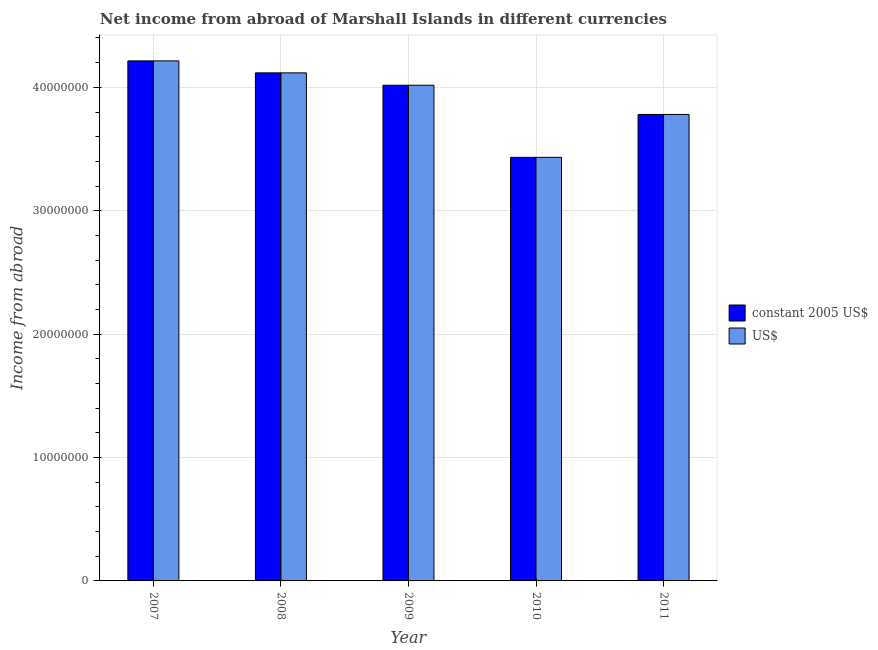How many different coloured bars are there?
Keep it short and to the point. 2. How many groups of bars are there?
Ensure brevity in your answer.  5. Are the number of bars per tick equal to the number of legend labels?
Provide a short and direct response. Yes. How many bars are there on the 2nd tick from the right?
Give a very brief answer. 2. What is the label of the 5th group of bars from the left?
Make the answer very short. 2011. What is the income from abroad in us$ in 2010?
Your response must be concise. 3.43e+07. Across all years, what is the maximum income from abroad in us$?
Provide a succinct answer. 4.21e+07. Across all years, what is the minimum income from abroad in us$?
Ensure brevity in your answer.  3.43e+07. In which year was the income from abroad in constant 2005 us$ minimum?
Ensure brevity in your answer.  2010. What is the total income from abroad in constant 2005 us$ in the graph?
Provide a short and direct response. 1.96e+08. What is the difference between the income from abroad in constant 2005 us$ in 2009 and that in 2010?
Your answer should be very brief. 5.84e+06. What is the difference between the income from abroad in constant 2005 us$ in 2008 and the income from abroad in us$ in 2010?
Give a very brief answer. 6.85e+06. What is the average income from abroad in constant 2005 us$ per year?
Keep it short and to the point. 3.91e+07. In how many years, is the income from abroad in us$ greater than 12000000 units?
Make the answer very short. 5. What is the ratio of the income from abroad in us$ in 2007 to that in 2009?
Make the answer very short. 1.05. Is the income from abroad in constant 2005 us$ in 2008 less than that in 2009?
Ensure brevity in your answer.  No. What is the difference between the highest and the second highest income from abroad in us$?
Ensure brevity in your answer.  9.72e+05. What is the difference between the highest and the lowest income from abroad in us$?
Provide a succinct answer. 7.82e+06. In how many years, is the income from abroad in constant 2005 us$ greater than the average income from abroad in constant 2005 us$ taken over all years?
Your response must be concise. 3. What does the 1st bar from the left in 2010 represents?
Offer a very short reply. Constant 2005 us$. What does the 1st bar from the right in 2010 represents?
Ensure brevity in your answer.  US$. How many bars are there?
Your answer should be very brief. 10. Are the values on the major ticks of Y-axis written in scientific E-notation?
Keep it short and to the point. No. Does the graph contain any zero values?
Your answer should be very brief. No. Where does the legend appear in the graph?
Offer a very short reply. Center right. How are the legend labels stacked?
Provide a succinct answer. Vertical. What is the title of the graph?
Provide a short and direct response. Net income from abroad of Marshall Islands in different currencies. What is the label or title of the Y-axis?
Ensure brevity in your answer.  Income from abroad. What is the Income from abroad in constant 2005 US$ in 2007?
Your answer should be compact. 4.21e+07. What is the Income from abroad of US$ in 2007?
Your response must be concise. 4.21e+07. What is the Income from abroad in constant 2005 US$ in 2008?
Offer a terse response. 4.12e+07. What is the Income from abroad in US$ in 2008?
Make the answer very short. 4.12e+07. What is the Income from abroad in constant 2005 US$ in 2009?
Provide a short and direct response. 4.02e+07. What is the Income from abroad of US$ in 2009?
Ensure brevity in your answer.  4.02e+07. What is the Income from abroad in constant 2005 US$ in 2010?
Your answer should be compact. 3.43e+07. What is the Income from abroad in US$ in 2010?
Offer a terse response. 3.43e+07. What is the Income from abroad in constant 2005 US$ in 2011?
Your answer should be very brief. 3.78e+07. What is the Income from abroad of US$ in 2011?
Provide a succinct answer. 3.78e+07. Across all years, what is the maximum Income from abroad in constant 2005 US$?
Keep it short and to the point. 4.21e+07. Across all years, what is the maximum Income from abroad in US$?
Give a very brief answer. 4.21e+07. Across all years, what is the minimum Income from abroad of constant 2005 US$?
Provide a succinct answer. 3.43e+07. Across all years, what is the minimum Income from abroad in US$?
Offer a very short reply. 3.43e+07. What is the total Income from abroad of constant 2005 US$ in the graph?
Your answer should be very brief. 1.96e+08. What is the total Income from abroad in US$ in the graph?
Offer a terse response. 1.96e+08. What is the difference between the Income from abroad of constant 2005 US$ in 2007 and that in 2008?
Give a very brief answer. 9.72e+05. What is the difference between the Income from abroad of US$ in 2007 and that in 2008?
Your answer should be compact. 9.72e+05. What is the difference between the Income from abroad in constant 2005 US$ in 2007 and that in 2009?
Provide a succinct answer. 1.97e+06. What is the difference between the Income from abroad in US$ in 2007 and that in 2009?
Ensure brevity in your answer.  1.97e+06. What is the difference between the Income from abroad in constant 2005 US$ in 2007 and that in 2010?
Your response must be concise. 7.82e+06. What is the difference between the Income from abroad in US$ in 2007 and that in 2010?
Make the answer very short. 7.82e+06. What is the difference between the Income from abroad of constant 2005 US$ in 2007 and that in 2011?
Your answer should be compact. 4.34e+06. What is the difference between the Income from abroad in US$ in 2007 and that in 2011?
Provide a succinct answer. 4.34e+06. What is the difference between the Income from abroad of constant 2005 US$ in 2008 and that in 2009?
Your answer should be compact. 1.00e+06. What is the difference between the Income from abroad of US$ in 2008 and that in 2009?
Offer a very short reply. 1.00e+06. What is the difference between the Income from abroad of constant 2005 US$ in 2008 and that in 2010?
Your answer should be compact. 6.85e+06. What is the difference between the Income from abroad of US$ in 2008 and that in 2010?
Make the answer very short. 6.85e+06. What is the difference between the Income from abroad in constant 2005 US$ in 2008 and that in 2011?
Keep it short and to the point. 3.37e+06. What is the difference between the Income from abroad in US$ in 2008 and that in 2011?
Make the answer very short. 3.37e+06. What is the difference between the Income from abroad in constant 2005 US$ in 2009 and that in 2010?
Your answer should be compact. 5.84e+06. What is the difference between the Income from abroad in US$ in 2009 and that in 2010?
Offer a terse response. 5.84e+06. What is the difference between the Income from abroad of constant 2005 US$ in 2009 and that in 2011?
Provide a succinct answer. 2.37e+06. What is the difference between the Income from abroad in US$ in 2009 and that in 2011?
Give a very brief answer. 2.37e+06. What is the difference between the Income from abroad of constant 2005 US$ in 2010 and that in 2011?
Provide a succinct answer. -3.48e+06. What is the difference between the Income from abroad of US$ in 2010 and that in 2011?
Ensure brevity in your answer.  -3.48e+06. What is the difference between the Income from abroad of constant 2005 US$ in 2007 and the Income from abroad of US$ in 2008?
Keep it short and to the point. 9.72e+05. What is the difference between the Income from abroad in constant 2005 US$ in 2007 and the Income from abroad in US$ in 2009?
Provide a succinct answer. 1.97e+06. What is the difference between the Income from abroad in constant 2005 US$ in 2007 and the Income from abroad in US$ in 2010?
Provide a succinct answer. 7.82e+06. What is the difference between the Income from abroad in constant 2005 US$ in 2007 and the Income from abroad in US$ in 2011?
Give a very brief answer. 4.34e+06. What is the difference between the Income from abroad of constant 2005 US$ in 2008 and the Income from abroad of US$ in 2009?
Provide a short and direct response. 1.00e+06. What is the difference between the Income from abroad of constant 2005 US$ in 2008 and the Income from abroad of US$ in 2010?
Offer a very short reply. 6.85e+06. What is the difference between the Income from abroad in constant 2005 US$ in 2008 and the Income from abroad in US$ in 2011?
Offer a terse response. 3.37e+06. What is the difference between the Income from abroad of constant 2005 US$ in 2009 and the Income from abroad of US$ in 2010?
Your response must be concise. 5.84e+06. What is the difference between the Income from abroad in constant 2005 US$ in 2009 and the Income from abroad in US$ in 2011?
Offer a terse response. 2.37e+06. What is the difference between the Income from abroad in constant 2005 US$ in 2010 and the Income from abroad in US$ in 2011?
Keep it short and to the point. -3.48e+06. What is the average Income from abroad in constant 2005 US$ per year?
Keep it short and to the point. 3.91e+07. What is the average Income from abroad of US$ per year?
Your answer should be very brief. 3.91e+07. In the year 2007, what is the difference between the Income from abroad in constant 2005 US$ and Income from abroad in US$?
Your response must be concise. 0. In the year 2008, what is the difference between the Income from abroad of constant 2005 US$ and Income from abroad of US$?
Give a very brief answer. 0. In the year 2009, what is the difference between the Income from abroad in constant 2005 US$ and Income from abroad in US$?
Provide a succinct answer. 0. In the year 2010, what is the difference between the Income from abroad in constant 2005 US$ and Income from abroad in US$?
Make the answer very short. 0. In the year 2011, what is the difference between the Income from abroad in constant 2005 US$ and Income from abroad in US$?
Provide a short and direct response. 0. What is the ratio of the Income from abroad of constant 2005 US$ in 2007 to that in 2008?
Your response must be concise. 1.02. What is the ratio of the Income from abroad in US$ in 2007 to that in 2008?
Offer a very short reply. 1.02. What is the ratio of the Income from abroad in constant 2005 US$ in 2007 to that in 2009?
Make the answer very short. 1.05. What is the ratio of the Income from abroad of US$ in 2007 to that in 2009?
Offer a terse response. 1.05. What is the ratio of the Income from abroad in constant 2005 US$ in 2007 to that in 2010?
Ensure brevity in your answer.  1.23. What is the ratio of the Income from abroad of US$ in 2007 to that in 2010?
Keep it short and to the point. 1.23. What is the ratio of the Income from abroad in constant 2005 US$ in 2007 to that in 2011?
Provide a short and direct response. 1.11. What is the ratio of the Income from abroad of US$ in 2007 to that in 2011?
Provide a succinct answer. 1.11. What is the ratio of the Income from abroad in constant 2005 US$ in 2008 to that in 2009?
Your response must be concise. 1.02. What is the ratio of the Income from abroad in US$ in 2008 to that in 2009?
Ensure brevity in your answer.  1.02. What is the ratio of the Income from abroad of constant 2005 US$ in 2008 to that in 2010?
Keep it short and to the point. 1.2. What is the ratio of the Income from abroad of US$ in 2008 to that in 2010?
Keep it short and to the point. 1.2. What is the ratio of the Income from abroad of constant 2005 US$ in 2008 to that in 2011?
Ensure brevity in your answer.  1.09. What is the ratio of the Income from abroad in US$ in 2008 to that in 2011?
Provide a succinct answer. 1.09. What is the ratio of the Income from abroad of constant 2005 US$ in 2009 to that in 2010?
Your answer should be very brief. 1.17. What is the ratio of the Income from abroad of US$ in 2009 to that in 2010?
Give a very brief answer. 1.17. What is the ratio of the Income from abroad in constant 2005 US$ in 2009 to that in 2011?
Your answer should be compact. 1.06. What is the ratio of the Income from abroad in US$ in 2009 to that in 2011?
Keep it short and to the point. 1.06. What is the ratio of the Income from abroad in constant 2005 US$ in 2010 to that in 2011?
Offer a very short reply. 0.91. What is the ratio of the Income from abroad in US$ in 2010 to that in 2011?
Your answer should be very brief. 0.91. What is the difference between the highest and the second highest Income from abroad of constant 2005 US$?
Ensure brevity in your answer.  9.72e+05. What is the difference between the highest and the second highest Income from abroad in US$?
Your answer should be compact. 9.72e+05. What is the difference between the highest and the lowest Income from abroad of constant 2005 US$?
Offer a terse response. 7.82e+06. What is the difference between the highest and the lowest Income from abroad in US$?
Offer a very short reply. 7.82e+06. 